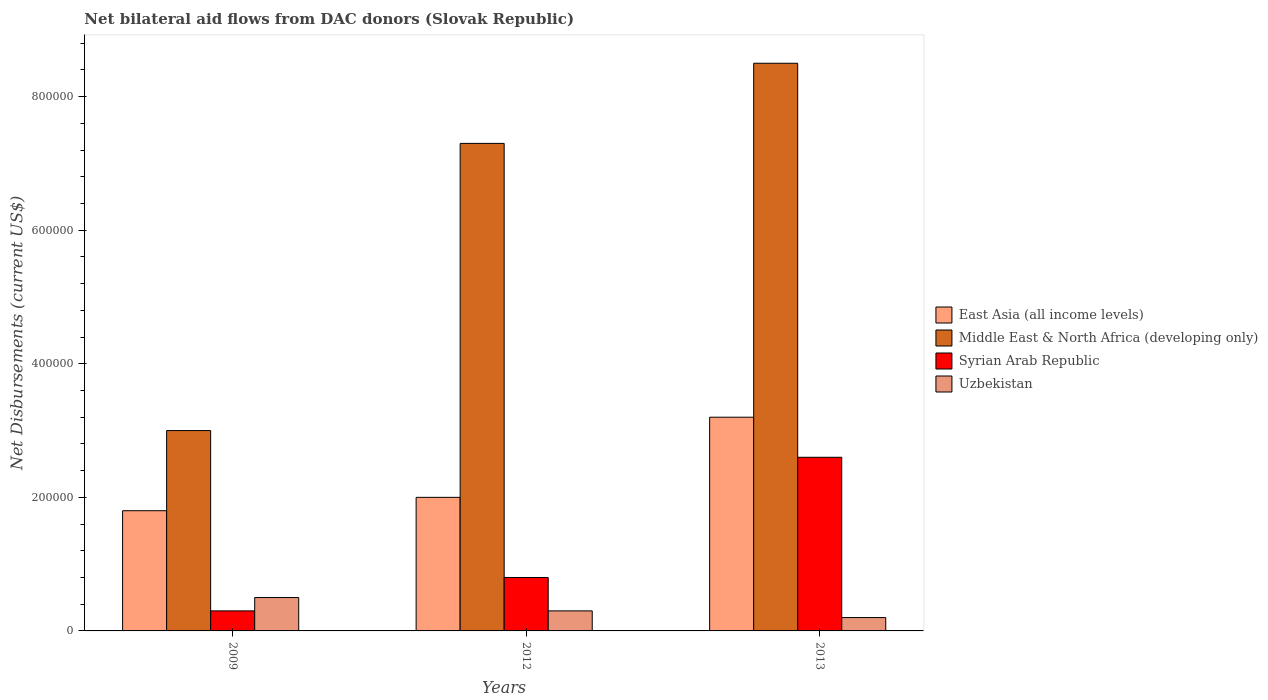How many groups of bars are there?
Your answer should be very brief. 3. Are the number of bars per tick equal to the number of legend labels?
Your response must be concise. Yes. Are the number of bars on each tick of the X-axis equal?
Your answer should be compact. Yes. How many bars are there on the 2nd tick from the left?
Provide a short and direct response. 4. In how many cases, is the number of bars for a given year not equal to the number of legend labels?
Your response must be concise. 0. Across all years, what is the maximum net bilateral aid flows in Middle East & North Africa (developing only)?
Offer a very short reply. 8.50e+05. Across all years, what is the minimum net bilateral aid flows in East Asia (all income levels)?
Offer a terse response. 1.80e+05. In which year was the net bilateral aid flows in East Asia (all income levels) minimum?
Your answer should be very brief. 2009. What is the total net bilateral aid flows in Syrian Arab Republic in the graph?
Your response must be concise. 3.70e+05. What is the difference between the net bilateral aid flows in Syrian Arab Republic in 2012 and the net bilateral aid flows in Middle East & North Africa (developing only) in 2013?
Provide a short and direct response. -7.70e+05. What is the average net bilateral aid flows in Middle East & North Africa (developing only) per year?
Make the answer very short. 6.27e+05. What is the ratio of the net bilateral aid flows in Syrian Arab Republic in 2009 to that in 2013?
Give a very brief answer. 0.12. What is the difference between the highest and the lowest net bilateral aid flows in Uzbekistan?
Your answer should be compact. 3.00e+04. Is it the case that in every year, the sum of the net bilateral aid flows in East Asia (all income levels) and net bilateral aid flows in Uzbekistan is greater than the sum of net bilateral aid flows in Middle East & North Africa (developing only) and net bilateral aid flows in Syrian Arab Republic?
Offer a terse response. Yes. What does the 3rd bar from the left in 2012 represents?
Ensure brevity in your answer.  Syrian Arab Republic. What does the 1st bar from the right in 2013 represents?
Provide a short and direct response. Uzbekistan. What is the difference between two consecutive major ticks on the Y-axis?
Your response must be concise. 2.00e+05. Are the values on the major ticks of Y-axis written in scientific E-notation?
Provide a short and direct response. No. Does the graph contain grids?
Make the answer very short. No. What is the title of the graph?
Offer a very short reply. Net bilateral aid flows from DAC donors (Slovak Republic). What is the label or title of the X-axis?
Your answer should be very brief. Years. What is the label or title of the Y-axis?
Provide a short and direct response. Net Disbursements (current US$). What is the Net Disbursements (current US$) in Syrian Arab Republic in 2009?
Provide a short and direct response. 3.00e+04. What is the Net Disbursements (current US$) of Middle East & North Africa (developing only) in 2012?
Your response must be concise. 7.30e+05. What is the Net Disbursements (current US$) of Middle East & North Africa (developing only) in 2013?
Offer a very short reply. 8.50e+05. What is the Net Disbursements (current US$) in Syrian Arab Republic in 2013?
Make the answer very short. 2.60e+05. Across all years, what is the maximum Net Disbursements (current US$) in East Asia (all income levels)?
Keep it short and to the point. 3.20e+05. Across all years, what is the maximum Net Disbursements (current US$) of Middle East & North Africa (developing only)?
Make the answer very short. 8.50e+05. What is the total Net Disbursements (current US$) in East Asia (all income levels) in the graph?
Your response must be concise. 7.00e+05. What is the total Net Disbursements (current US$) in Middle East & North Africa (developing only) in the graph?
Provide a short and direct response. 1.88e+06. What is the total Net Disbursements (current US$) in Syrian Arab Republic in the graph?
Ensure brevity in your answer.  3.70e+05. What is the total Net Disbursements (current US$) of Uzbekistan in the graph?
Your response must be concise. 1.00e+05. What is the difference between the Net Disbursements (current US$) of East Asia (all income levels) in 2009 and that in 2012?
Your answer should be very brief. -2.00e+04. What is the difference between the Net Disbursements (current US$) in Middle East & North Africa (developing only) in 2009 and that in 2012?
Your response must be concise. -4.30e+05. What is the difference between the Net Disbursements (current US$) in Uzbekistan in 2009 and that in 2012?
Ensure brevity in your answer.  2.00e+04. What is the difference between the Net Disbursements (current US$) of East Asia (all income levels) in 2009 and that in 2013?
Offer a very short reply. -1.40e+05. What is the difference between the Net Disbursements (current US$) in Middle East & North Africa (developing only) in 2009 and that in 2013?
Your answer should be compact. -5.50e+05. What is the difference between the Net Disbursements (current US$) of Middle East & North Africa (developing only) in 2012 and that in 2013?
Give a very brief answer. -1.20e+05. What is the difference between the Net Disbursements (current US$) of East Asia (all income levels) in 2009 and the Net Disbursements (current US$) of Middle East & North Africa (developing only) in 2012?
Your answer should be compact. -5.50e+05. What is the difference between the Net Disbursements (current US$) in East Asia (all income levels) in 2009 and the Net Disbursements (current US$) in Syrian Arab Republic in 2012?
Your answer should be very brief. 1.00e+05. What is the difference between the Net Disbursements (current US$) in Middle East & North Africa (developing only) in 2009 and the Net Disbursements (current US$) in Uzbekistan in 2012?
Make the answer very short. 2.70e+05. What is the difference between the Net Disbursements (current US$) in Syrian Arab Republic in 2009 and the Net Disbursements (current US$) in Uzbekistan in 2012?
Offer a very short reply. 0. What is the difference between the Net Disbursements (current US$) in East Asia (all income levels) in 2009 and the Net Disbursements (current US$) in Middle East & North Africa (developing only) in 2013?
Keep it short and to the point. -6.70e+05. What is the difference between the Net Disbursements (current US$) in East Asia (all income levels) in 2009 and the Net Disbursements (current US$) in Syrian Arab Republic in 2013?
Offer a terse response. -8.00e+04. What is the difference between the Net Disbursements (current US$) in East Asia (all income levels) in 2009 and the Net Disbursements (current US$) in Uzbekistan in 2013?
Make the answer very short. 1.60e+05. What is the difference between the Net Disbursements (current US$) of Middle East & North Africa (developing only) in 2009 and the Net Disbursements (current US$) of Syrian Arab Republic in 2013?
Provide a short and direct response. 4.00e+04. What is the difference between the Net Disbursements (current US$) in Middle East & North Africa (developing only) in 2009 and the Net Disbursements (current US$) in Uzbekistan in 2013?
Your answer should be compact. 2.80e+05. What is the difference between the Net Disbursements (current US$) of East Asia (all income levels) in 2012 and the Net Disbursements (current US$) of Middle East & North Africa (developing only) in 2013?
Your answer should be very brief. -6.50e+05. What is the difference between the Net Disbursements (current US$) of East Asia (all income levels) in 2012 and the Net Disbursements (current US$) of Syrian Arab Republic in 2013?
Ensure brevity in your answer.  -6.00e+04. What is the difference between the Net Disbursements (current US$) in East Asia (all income levels) in 2012 and the Net Disbursements (current US$) in Uzbekistan in 2013?
Offer a terse response. 1.80e+05. What is the difference between the Net Disbursements (current US$) in Middle East & North Africa (developing only) in 2012 and the Net Disbursements (current US$) in Uzbekistan in 2013?
Your answer should be compact. 7.10e+05. What is the difference between the Net Disbursements (current US$) in Syrian Arab Republic in 2012 and the Net Disbursements (current US$) in Uzbekistan in 2013?
Your answer should be compact. 6.00e+04. What is the average Net Disbursements (current US$) of East Asia (all income levels) per year?
Give a very brief answer. 2.33e+05. What is the average Net Disbursements (current US$) in Middle East & North Africa (developing only) per year?
Your answer should be compact. 6.27e+05. What is the average Net Disbursements (current US$) of Syrian Arab Republic per year?
Offer a very short reply. 1.23e+05. What is the average Net Disbursements (current US$) in Uzbekistan per year?
Make the answer very short. 3.33e+04. In the year 2009, what is the difference between the Net Disbursements (current US$) in East Asia (all income levels) and Net Disbursements (current US$) in Middle East & North Africa (developing only)?
Provide a succinct answer. -1.20e+05. In the year 2009, what is the difference between the Net Disbursements (current US$) in East Asia (all income levels) and Net Disbursements (current US$) in Syrian Arab Republic?
Ensure brevity in your answer.  1.50e+05. In the year 2009, what is the difference between the Net Disbursements (current US$) in East Asia (all income levels) and Net Disbursements (current US$) in Uzbekistan?
Provide a short and direct response. 1.30e+05. In the year 2009, what is the difference between the Net Disbursements (current US$) of Middle East & North Africa (developing only) and Net Disbursements (current US$) of Syrian Arab Republic?
Keep it short and to the point. 2.70e+05. In the year 2009, what is the difference between the Net Disbursements (current US$) in Syrian Arab Republic and Net Disbursements (current US$) in Uzbekistan?
Keep it short and to the point. -2.00e+04. In the year 2012, what is the difference between the Net Disbursements (current US$) of East Asia (all income levels) and Net Disbursements (current US$) of Middle East & North Africa (developing only)?
Offer a terse response. -5.30e+05. In the year 2012, what is the difference between the Net Disbursements (current US$) in East Asia (all income levels) and Net Disbursements (current US$) in Uzbekistan?
Provide a succinct answer. 1.70e+05. In the year 2012, what is the difference between the Net Disbursements (current US$) in Middle East & North Africa (developing only) and Net Disbursements (current US$) in Syrian Arab Republic?
Provide a succinct answer. 6.50e+05. In the year 2012, what is the difference between the Net Disbursements (current US$) of Middle East & North Africa (developing only) and Net Disbursements (current US$) of Uzbekistan?
Your answer should be very brief. 7.00e+05. In the year 2012, what is the difference between the Net Disbursements (current US$) of Syrian Arab Republic and Net Disbursements (current US$) of Uzbekistan?
Your response must be concise. 5.00e+04. In the year 2013, what is the difference between the Net Disbursements (current US$) in East Asia (all income levels) and Net Disbursements (current US$) in Middle East & North Africa (developing only)?
Your answer should be very brief. -5.30e+05. In the year 2013, what is the difference between the Net Disbursements (current US$) in East Asia (all income levels) and Net Disbursements (current US$) in Uzbekistan?
Keep it short and to the point. 3.00e+05. In the year 2013, what is the difference between the Net Disbursements (current US$) in Middle East & North Africa (developing only) and Net Disbursements (current US$) in Syrian Arab Republic?
Make the answer very short. 5.90e+05. In the year 2013, what is the difference between the Net Disbursements (current US$) in Middle East & North Africa (developing only) and Net Disbursements (current US$) in Uzbekistan?
Your response must be concise. 8.30e+05. What is the ratio of the Net Disbursements (current US$) of Middle East & North Africa (developing only) in 2009 to that in 2012?
Offer a very short reply. 0.41. What is the ratio of the Net Disbursements (current US$) in East Asia (all income levels) in 2009 to that in 2013?
Provide a succinct answer. 0.56. What is the ratio of the Net Disbursements (current US$) of Middle East & North Africa (developing only) in 2009 to that in 2013?
Offer a very short reply. 0.35. What is the ratio of the Net Disbursements (current US$) in Syrian Arab Republic in 2009 to that in 2013?
Make the answer very short. 0.12. What is the ratio of the Net Disbursements (current US$) of Uzbekistan in 2009 to that in 2013?
Your answer should be compact. 2.5. What is the ratio of the Net Disbursements (current US$) in Middle East & North Africa (developing only) in 2012 to that in 2013?
Provide a succinct answer. 0.86. What is the ratio of the Net Disbursements (current US$) of Syrian Arab Republic in 2012 to that in 2013?
Provide a succinct answer. 0.31. What is the ratio of the Net Disbursements (current US$) of Uzbekistan in 2012 to that in 2013?
Make the answer very short. 1.5. What is the difference between the highest and the lowest Net Disbursements (current US$) of Middle East & North Africa (developing only)?
Provide a succinct answer. 5.50e+05. What is the difference between the highest and the lowest Net Disbursements (current US$) in Syrian Arab Republic?
Provide a succinct answer. 2.30e+05. What is the difference between the highest and the lowest Net Disbursements (current US$) of Uzbekistan?
Offer a terse response. 3.00e+04. 